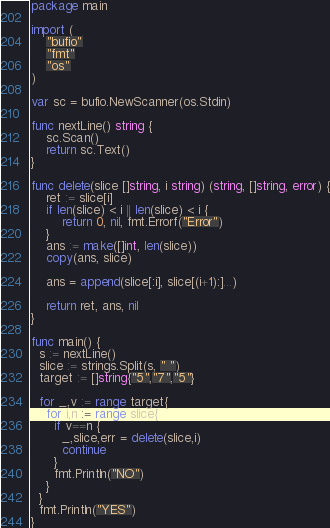Convert code to text. <code><loc_0><loc_0><loc_500><loc_500><_Go_>package main
 
import (
    "bufio"
    "fmt"
    "os"
)
 
var sc = bufio.NewScanner(os.Stdin)
 
func nextLine() string {
    sc.Scan()
    return sc.Text()
}
 
func delete(slice []string, i string) (string, []string, error) {
    ret := slice[i]
    if len(slice) < i || len(slice) < i {
        return 0, nil, fmt.Errorf("Error")
    }
    ans := make([]int, len(slice))
    copy(ans, slice)
 
    ans = append(slice[:i], slice[(i+1):]...)
 
    return ret, ans, nil
}
 
func main() {
  s := nextLine()
  slice := strings.Split(s, " ")
  target := []string{"5","7","5"}
  
  for _,v := range target{
    for i,n := range slice{
      if v==n {
        _,slice,err = delete(slice,i)
        continue
      }
      fmt.Println("NO")
    }
  }
  fmt.Println("YES")
}</code> 